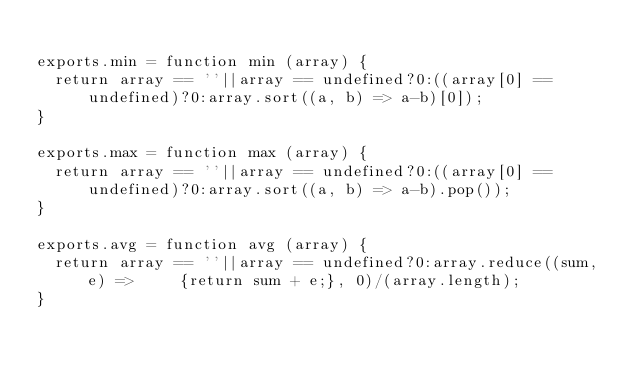Convert code to text. <code><loc_0><loc_0><loc_500><loc_500><_JavaScript_>
exports.min = function min (array) {
  return array == ''||array == undefined?0:((array[0] ==undefined)?0:array.sort((a, b) => a-b)[0]);
}

exports.max = function max (array) {
  return array == ''||array == undefined?0:((array[0] ==undefined)?0:array.sort((a, b) => a-b).pop());
}

exports.avg = function avg (array) {
  return array == ''||array == undefined?0:array.reduce((sum, e) => 	{return sum + e;}, 0)/(array.length);
}
</code> 